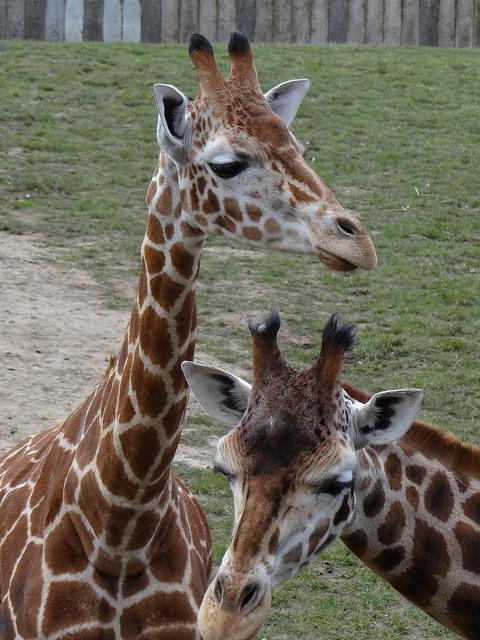How many giraffes are there?
Give a very brief answer. 2. How many animals are seen in the picture?
Give a very brief answer. 2. How many giraffes are in the photo?
Give a very brief answer. 2. How many gazelles?
Give a very brief answer. 0. How many giraffes can be seen?
Give a very brief answer. 2. How many people are to the right of the train?
Give a very brief answer. 0. 